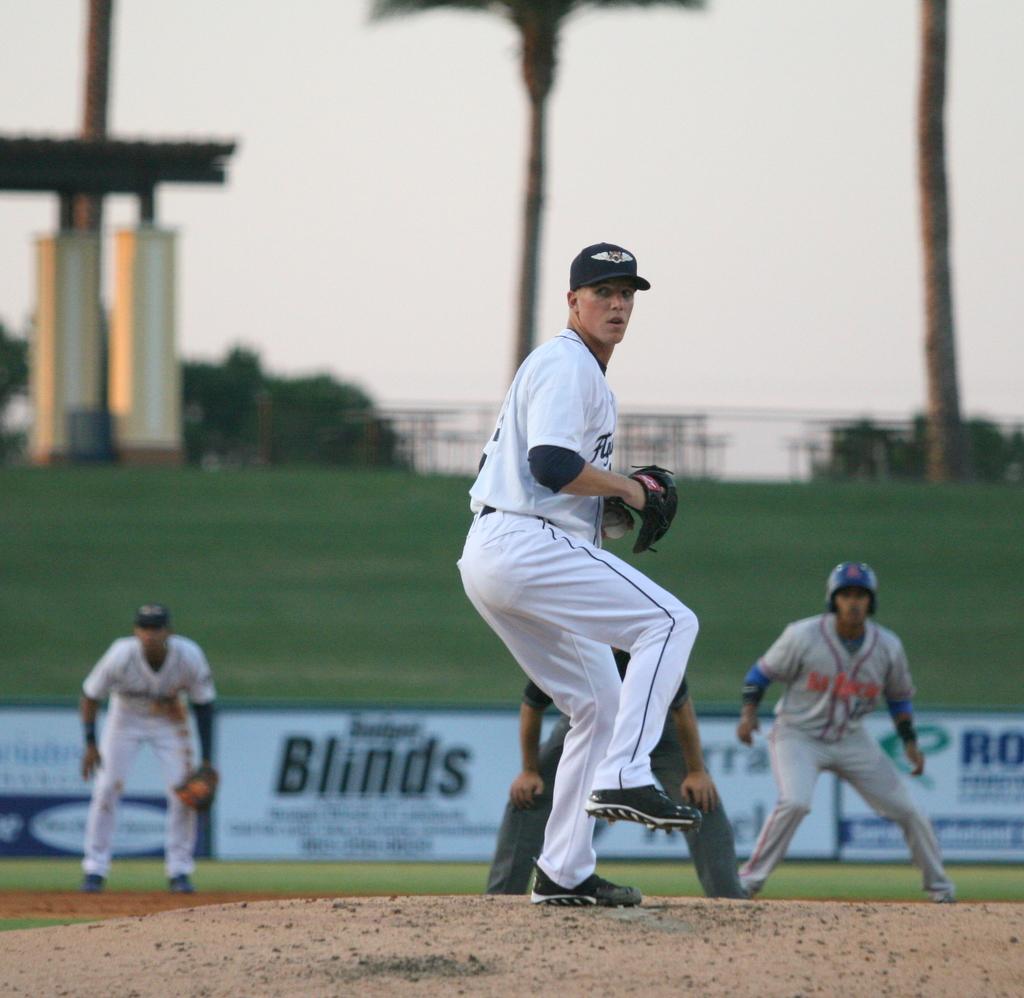What is the word in the background that starts with b?
Your answer should be compact. Blinds. 